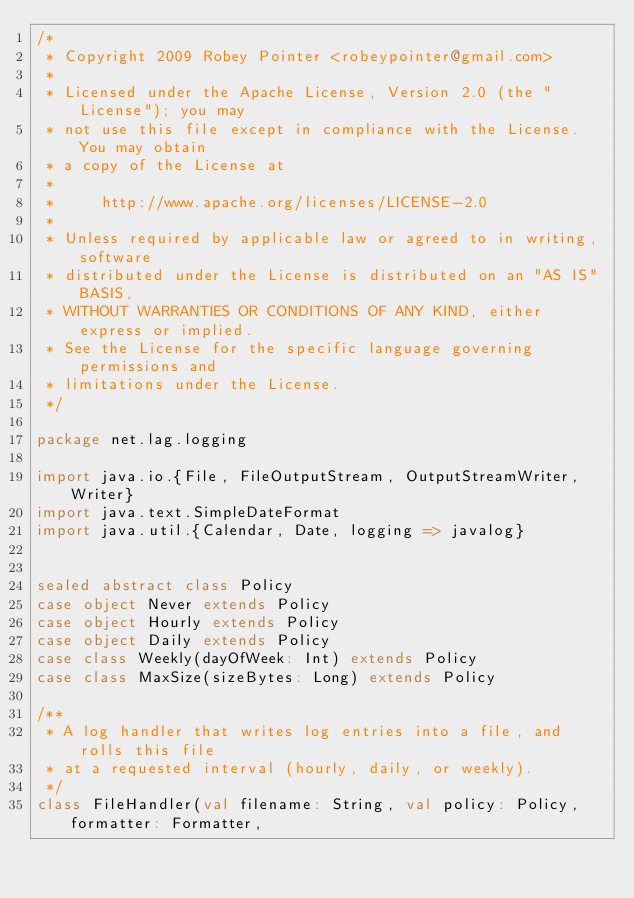Convert code to text. <code><loc_0><loc_0><loc_500><loc_500><_Scala_>/*
 * Copyright 2009 Robey Pointer <robeypointer@gmail.com>
 *
 * Licensed under the Apache License, Version 2.0 (the "License"); you may
 * not use this file except in compliance with the License. You may obtain
 * a copy of the License at
 *
 *     http://www.apache.org/licenses/LICENSE-2.0
 *
 * Unless required by applicable law or agreed to in writing, software
 * distributed under the License is distributed on an "AS IS" BASIS,
 * WITHOUT WARRANTIES OR CONDITIONS OF ANY KIND, either express or implied.
 * See the License for the specific language governing permissions and
 * limitations under the License.
 */

package net.lag.logging

import java.io.{File, FileOutputStream, OutputStreamWriter, Writer}
import java.text.SimpleDateFormat
import java.util.{Calendar, Date, logging => javalog}


sealed abstract class Policy
case object Never extends Policy
case object Hourly extends Policy
case object Daily extends Policy
case class Weekly(dayOfWeek: Int) extends Policy
case class MaxSize(sizeBytes: Long) extends Policy

/**
 * A log handler that writes log entries into a file, and rolls this file
 * at a requested interval (hourly, daily, or weekly).
 */
class FileHandler(val filename: String, val policy: Policy, formatter: Formatter,</code> 